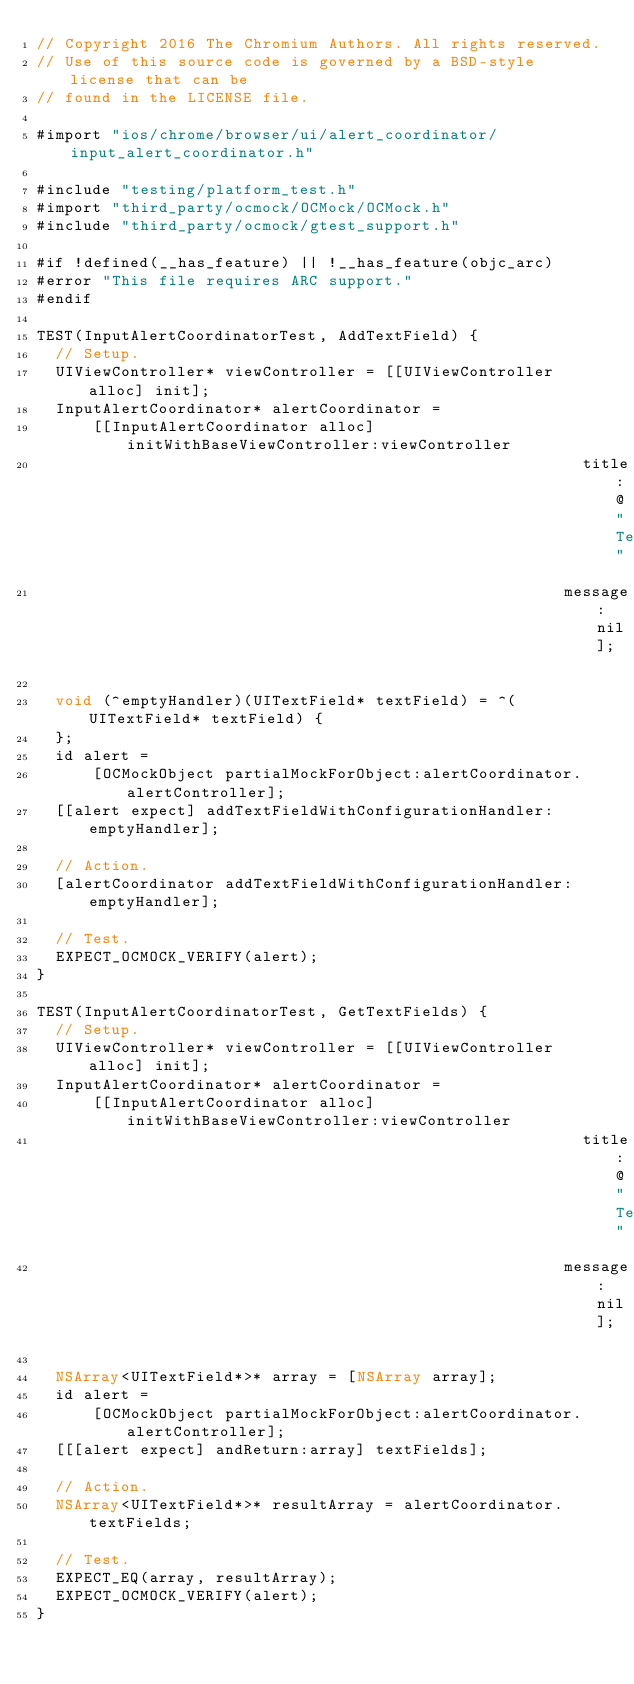<code> <loc_0><loc_0><loc_500><loc_500><_ObjectiveC_>// Copyright 2016 The Chromium Authors. All rights reserved.
// Use of this source code is governed by a BSD-style license that can be
// found in the LICENSE file.

#import "ios/chrome/browser/ui/alert_coordinator/input_alert_coordinator.h"

#include "testing/platform_test.h"
#import "third_party/ocmock/OCMock/OCMock.h"
#include "third_party/ocmock/gtest_support.h"

#if !defined(__has_feature) || !__has_feature(objc_arc)
#error "This file requires ARC support."
#endif

TEST(InputAlertCoordinatorTest, AddTextField) {
  // Setup.
  UIViewController* viewController = [[UIViewController alloc] init];
  InputAlertCoordinator* alertCoordinator =
      [[InputAlertCoordinator alloc] initWithBaseViewController:viewController
                                                          title:@"Test"
                                                        message:nil];

  void (^emptyHandler)(UITextField* textField) = ^(UITextField* textField) {
  };
  id alert =
      [OCMockObject partialMockForObject:alertCoordinator.alertController];
  [[alert expect] addTextFieldWithConfigurationHandler:emptyHandler];

  // Action.
  [alertCoordinator addTextFieldWithConfigurationHandler:emptyHandler];

  // Test.
  EXPECT_OCMOCK_VERIFY(alert);
}

TEST(InputAlertCoordinatorTest, GetTextFields) {
  // Setup.
  UIViewController* viewController = [[UIViewController alloc] init];
  InputAlertCoordinator* alertCoordinator =
      [[InputAlertCoordinator alloc] initWithBaseViewController:viewController
                                                          title:@"Test"
                                                        message:nil];

  NSArray<UITextField*>* array = [NSArray array];
  id alert =
      [OCMockObject partialMockForObject:alertCoordinator.alertController];
  [[[alert expect] andReturn:array] textFields];

  // Action.
  NSArray<UITextField*>* resultArray = alertCoordinator.textFields;

  // Test.
  EXPECT_EQ(array, resultArray);
  EXPECT_OCMOCK_VERIFY(alert);
}
</code> 